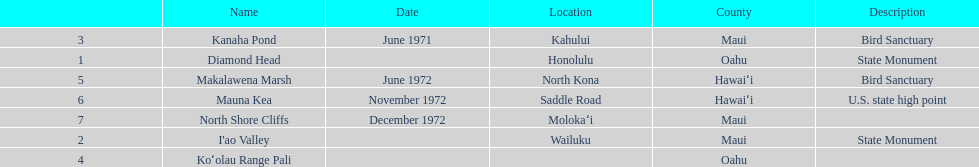Which county is featured the most on the chart? Maui. 